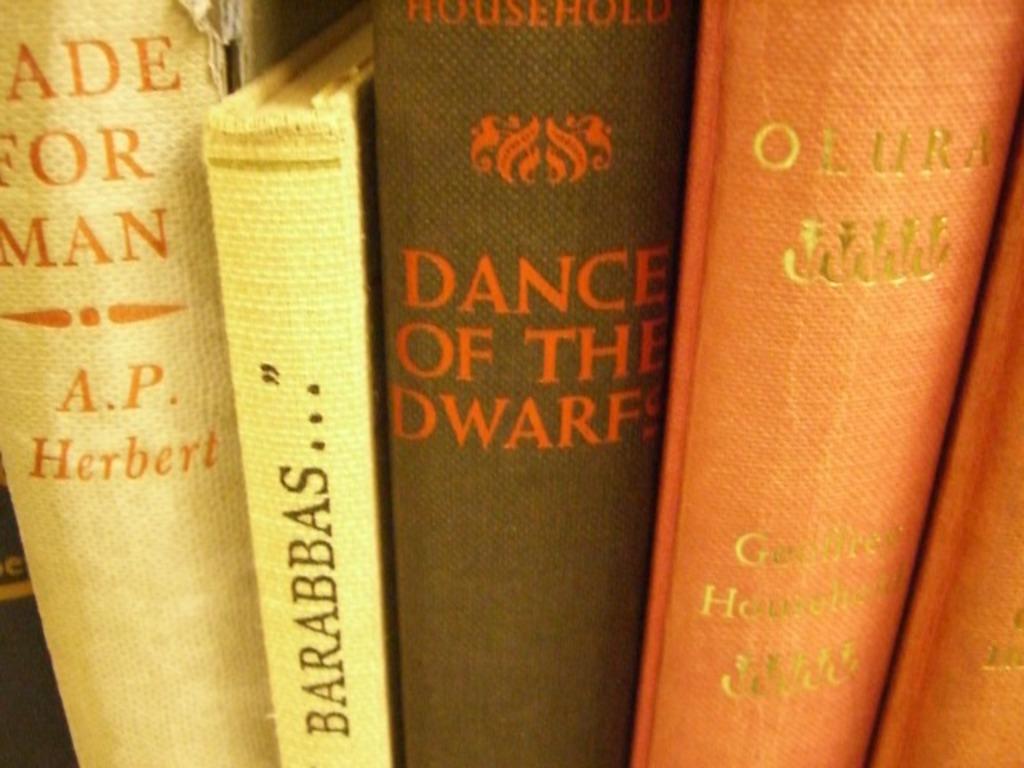Who is the author of the white book on the left end?
Offer a very short reply. A.p. herbert. 